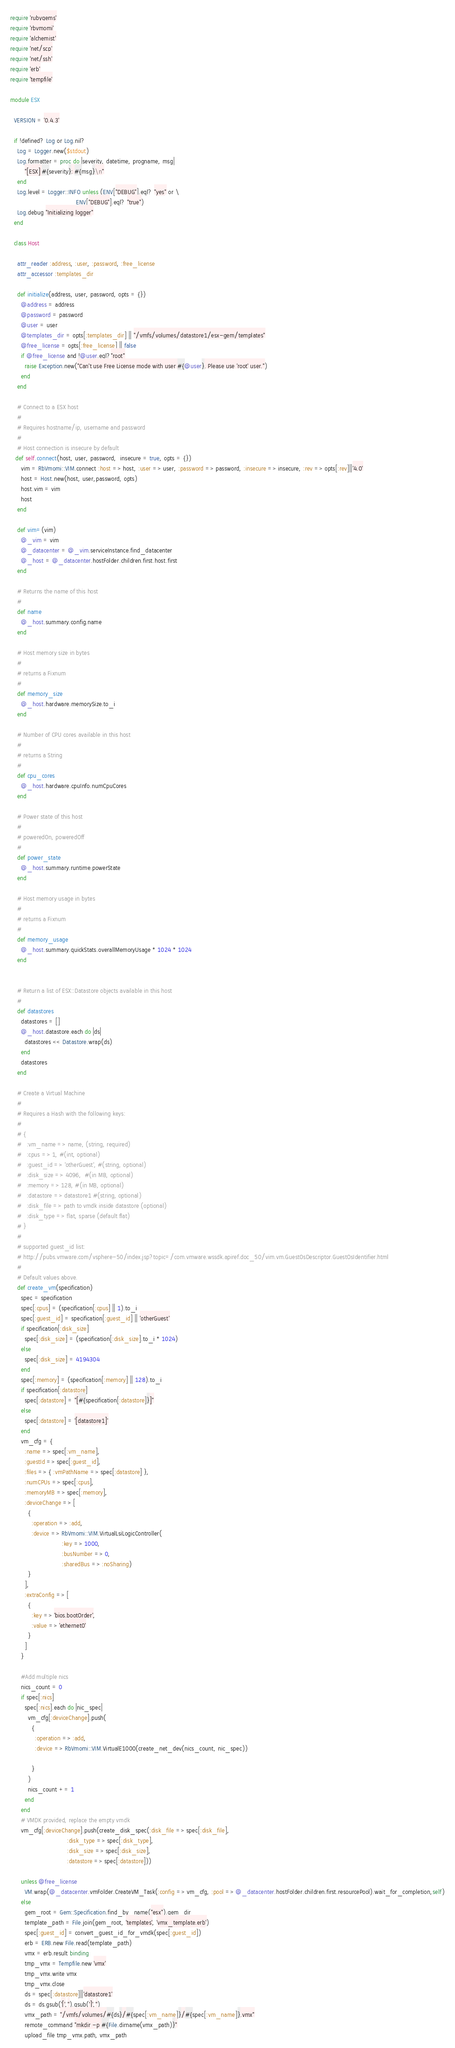<code> <loc_0><loc_0><loc_500><loc_500><_Ruby_>require 'rubygems'
require 'rbvmomi'
require 'alchemist'
require 'net/scp'
require 'net/ssh'
require 'erb'
require 'tempfile'

module ESX

  VERSION = '0.4.3'

  if !defined? Log or Log.nil?
    Log = Logger.new($stdout)
    Log.formatter = proc do |severity, datetime, progname, msg|
        "[ESX] #{severity}: #{msg}\n"
    end
    Log.level = Logger::INFO unless (ENV["DEBUG"].eql? "yes" or \
                                     ENV["DEBUG"].eql? "true")
    Log.debug "Initializing logger"
  end

  class Host

    attr_reader :address, :user, :password, :free_license
    attr_accessor :templates_dir

    def initialize(address, user, password, opts = {})
      @address = address
      @password = password
      @user = user
      @templates_dir = opts[:templates_dir] || "/vmfs/volumes/datastore1/esx-gem/templates"
      @free_license = opts[:free_license] || false
      if @free_license and !@user.eql?"root"
        raise Exception.new("Can't use Free License mode with user #{@user}. Please use 'root' user.")
      end
    end

    # Connect to a ESX host
    #
    # Requires hostname/ip, username and password
    #
    # Host connection is insecure by default
   def self.connect(host, user, password,  insecure = true, opts = {})
      vim = RbVmomi::VIM.connect :host => host, :user => user, :password => password, :insecure => insecure, :rev => opts[:rev]||'4.0'
      host = Host.new(host, user,password, opts)
      host.vim = vim
      host
    end

    def vim=(vim)
      @_vim = vim
      @_datacenter = @_vim.serviceInstance.find_datacenter
      @_host = @_datacenter.hostFolder.children.first.host.first
    end

    # Returns the name of this host
    #
    def name
      @_host.summary.config.name
    end

    # Host memory size in bytes
    #
    # returns a Fixnum
    #
    def memory_size
      @_host.hardware.memorySize.to_i
    end

    # Number of CPU cores available in this host
    #
    # returns a String
    #
    def cpu_cores
      @_host.hardware.cpuInfo.numCpuCores
    end

    # Power state of this host
    #
    # poweredOn, poweredOff
    #
    def power_state
      @_host.summary.runtime.powerState
    end

    # Host memory usage in bytes
    #
    # returns a Fixnum
    #
    def memory_usage
      @_host.summary.quickStats.overallMemoryUsage * 1024 * 1024
    end


    # Return a list of ESX::Datastore objects available in this host
    #
    def datastores
      datastores = []
      @_host.datastore.each do |ds|
        datastores << Datastore.wrap(ds)
      end
      datastores
    end

    # Create a Virtual Machine
    #
    # Requires a Hash with the following keys:
    #
    # {
    #   :vm_name => name, (string, required)
    #   :cpus => 1, #(int, optional)
    #   :guest_id => 'otherGuest', #(string, optional)
    #   :disk_size => 4096,  #(in MB, optional)
    #   :memory => 128, #(in MB, optional)
    #   :datastore => datastore1 #(string, optional)
    #   :disk_file => path to vmdk inside datastore (optional)
    #   :disk_type => flat, sparse (default flat)
    # }
    #
    # supported guest_id list:
    # http://pubs.vmware.com/vsphere-50/index.jsp?topic=/com.vmware.wssdk.apiref.doc_50/vim.vm.GuestOsDescriptor.GuestOsIdentifier.html
    #
    # Default values above.
    def create_vm(specification)
      spec = specification
      spec[:cpus] = (specification[:cpus] || 1).to_i
      spec[:guest_id] = specification[:guest_id] || 'otherGuest'
      if specification[:disk_size]
        spec[:disk_size] = (specification[:disk_size].to_i * 1024)
      else
        spec[:disk_size] = 4194304
      end
      spec[:memory] = (specification[:memory] || 128).to_i
      if specification[:datastore]
        spec[:datastore] = "[#{specification[:datastore]}]"
      else
        spec[:datastore] = '[datastore1]'
      end
      vm_cfg = {
        :name => spec[:vm_name],
        :guestId => spec[:guest_id],
        :files => { :vmPathName => spec[:datastore] },
        :numCPUs => spec[:cpus],
        :memoryMB => spec[:memory],
        :deviceChange => [
          {
            :operation => :add,
            :device => RbVmomi::VIM.VirtualLsiLogicController(
                             :key => 1000,
                             :busNumber => 0,
                             :sharedBus => :noSharing)
          }
        ],
        :extraConfig => [
          {
            :key => 'bios.bootOrder',
            :value => 'ethernet0'
          }
        ]
      }

      #Add multiple nics
      nics_count = 0
      if spec[:nics]
        spec[:nics].each do |nic_spec|
          vm_cfg[:deviceChange].push(
            {
              :operation => :add,
              :device => RbVmomi::VIM.VirtualE1000(create_net_dev(nics_count, nic_spec))

            }
          )
          nics_count += 1
        end
      end
      # VMDK provided, replace the empty vmdk
      vm_cfg[:deviceChange].push(create_disk_spec(:disk_file => spec[:disk_file],
                                :disk_type => spec[:disk_type],
                                :disk_size => spec[:disk_size],
                                :datastore => spec[:datastore]))

      unless @free_license
        VM.wrap(@_datacenter.vmFolder.CreateVM_Task(:config => vm_cfg, :pool => @_datacenter.hostFolder.children.first.resourcePool).wait_for_completion,self)
      else
        gem_root = Gem::Specification.find_by_name("esx").gem_dir
        template_path = File.join(gem_root, 'templates', 'vmx_template.erb')
        spec[:guest_id] = convert_guest_id_for_vmdk(spec[:guest_id])
        erb = ERB.new File.read(template_path)
        vmx = erb.result binding
        tmp_vmx = Tempfile.new 'vmx'
        tmp_vmx.write vmx
        tmp_vmx.close
        ds = spec[:datastore]||'datastore1'
        ds = ds.gsub('[','').gsub(']','')
        vmx_path = "/vmfs/volumes/#{ds}/#{spec[:vm_name]}/#{spec[:vm_name]}.vmx"
        remote_command "mkdir -p #{File.dirname(vmx_path)}"
        upload_file tmp_vmx.path, vmx_path</code> 